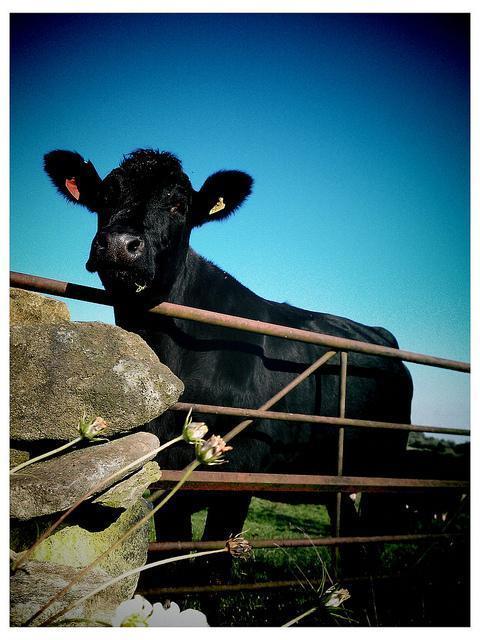How many cows are there?
Give a very brief answer. 2. 